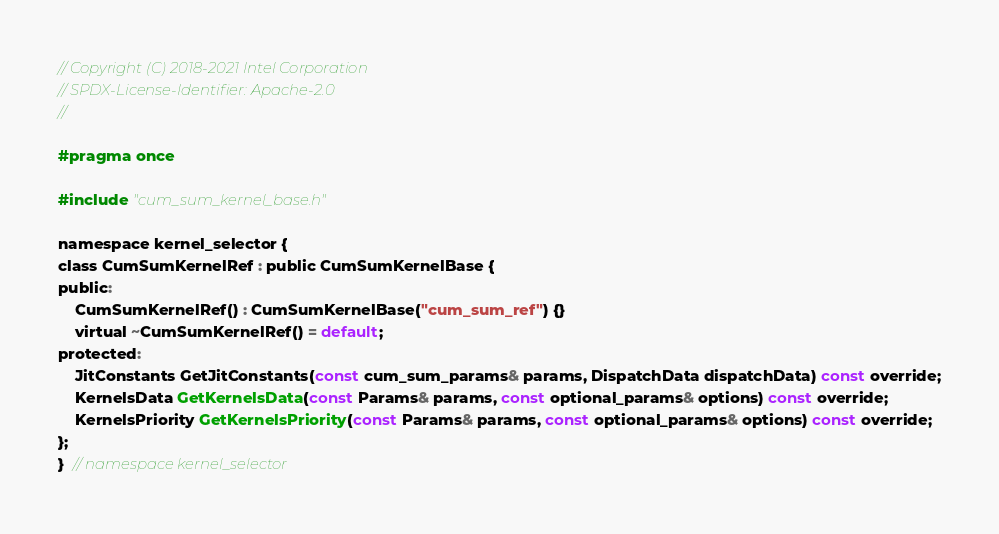<code> <loc_0><loc_0><loc_500><loc_500><_C_>// Copyright (C) 2018-2021 Intel Corporation
// SPDX-License-Identifier: Apache-2.0
//

#pragma once

#include "cum_sum_kernel_base.h"

namespace kernel_selector {
class CumSumKernelRef : public CumSumKernelBase {
public:
    CumSumKernelRef() : CumSumKernelBase("cum_sum_ref") {}
    virtual ~CumSumKernelRef() = default;
protected:
    JitConstants GetJitConstants(const cum_sum_params& params, DispatchData dispatchData) const override;
    KernelsData GetKernelsData(const Params& params, const optional_params& options) const override;
    KernelsPriority GetKernelsPriority(const Params& params, const optional_params& options) const override;
};
}  // namespace kernel_selector
</code> 